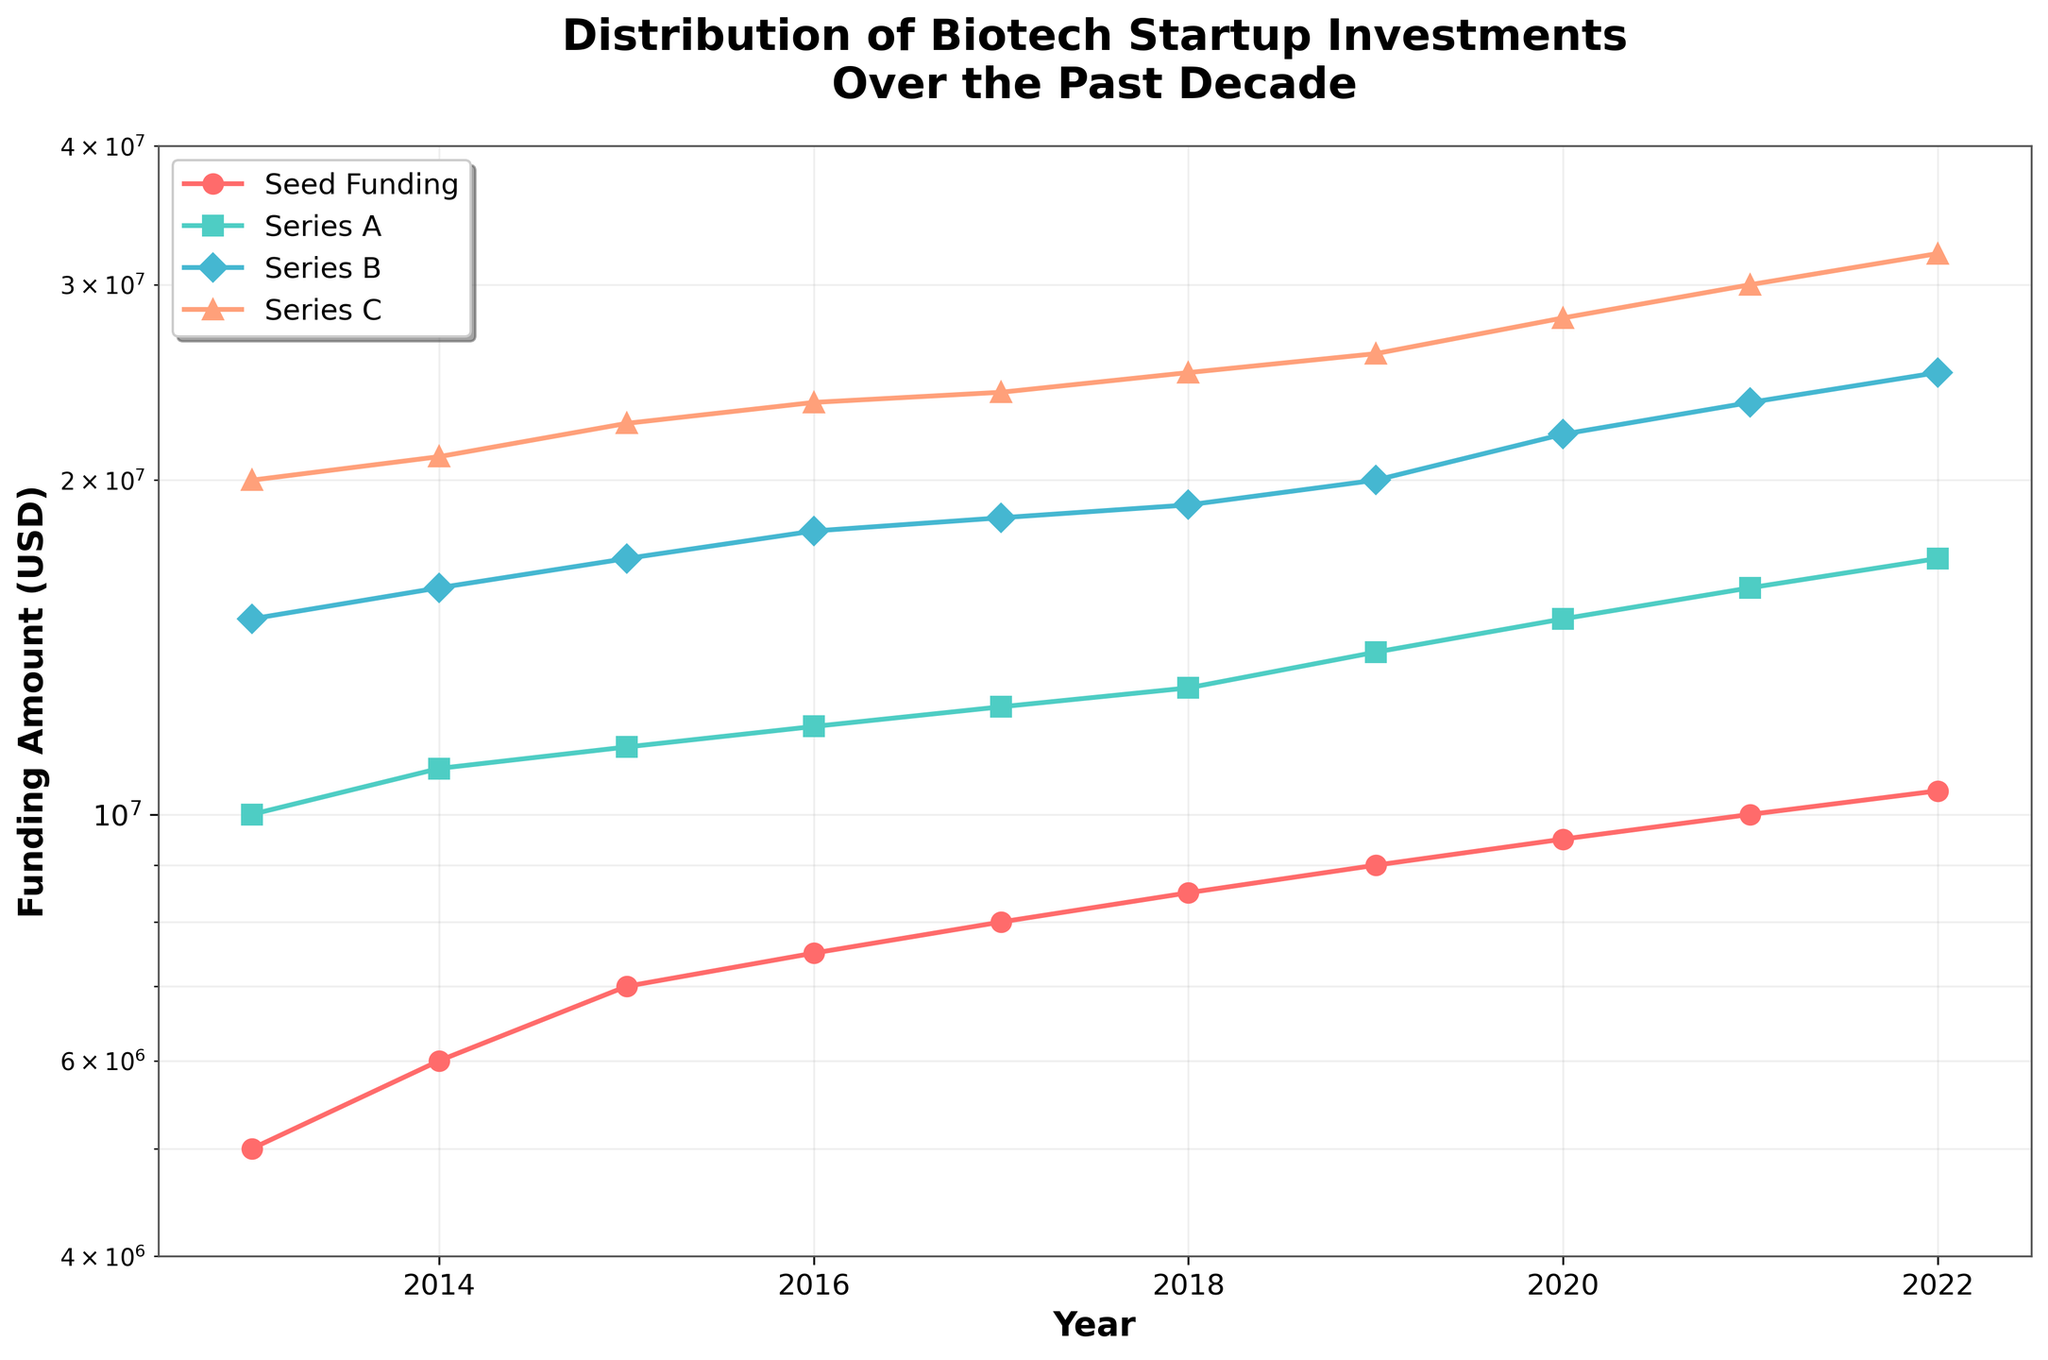What is the title of the plot? The title of the plot is typically the text shown at the top, which provides the overall summary of the depicted data. The title in this case is "Distribution of Biotech Startup Investments Over the Past Decade".
Answer: Distribution of Biotech Startup Investments Over the Past Decade What are the funding stages in the plot? To identify the funding stages, look at the legend at the top left corner of the plot. It lists the stages as labeled lines. The stages are Seed Funding, Series A, Series B, and Series C.
Answer: Seed Funding, Series A, Series B, Series C Which funding stage showed the most growth over the decade? To determine which funding stage showed the most growth, compare the starting and ending values for each stage. Seed funding started at 5 million and ended at 10.5 million, Series A from 10 million to 17 million, Series B from 15 million to 25 million, and Series C from 20 million to 32 million. The growth is highest for Series C.
Answer: Series C What are the y-axis limits of the plot? The y-axis limits can be observed directly by looking at the range specified along the axis. The plot ranges from 4 million USD to 40 million USD on a logarithmic scale.
Answer: 4 million USD to 40 million USD How does the funding amount in 2020 compare between Seed Funding and Series B? To compare the funding amounts, identify the values for each stage in 2020. The Seed Funding amount in 2020 is 9.5 million and the Series B amount is 22 million. Series B is significantly higher than Seed Funding.
Answer: Series B Which year had the highest total funding across all stages? To find the highest total funding year, sum the values for all stages in each year and compare. Summing the stages for each year, it can be seen 2022 has the highest.
Answer: 2022 What was the difference in Series A funding between the years 2015 and 2019? The Series A funding in 2015 was 11.5 million and in 2019 it was 14 million. The difference between these values is 2.5 million.
Answer: 2.5 million USD What pattern is visible in the funding of Series B over the decade? Observing the trend line for Series B over the years, it shows a steady increase from 15 million in 2013 to 25 million in 2022, indicating consistent growth.
Answer: Consistent growth What's the average Series C funding amount over the decade? Sum the Series C funding values from 2013 to 2022 and then divide by the number of years (10). Total Series C funding is 24 + 21 + 23.5 + 32 (in millions), resulting in an average of 24 + 21 + 23.5 +32 / 4 = 25.125 million.
Answer: 25.125 million USD In which year was the increase in Seed Funding from the previous year the highest? Calculate the year-over-year differences for Seed Funding and identify the year with the maximum difference. The year 2013-2013,2015-2014-2015 etc... 2021 has the highest jump from previous year
Answer: 2021 